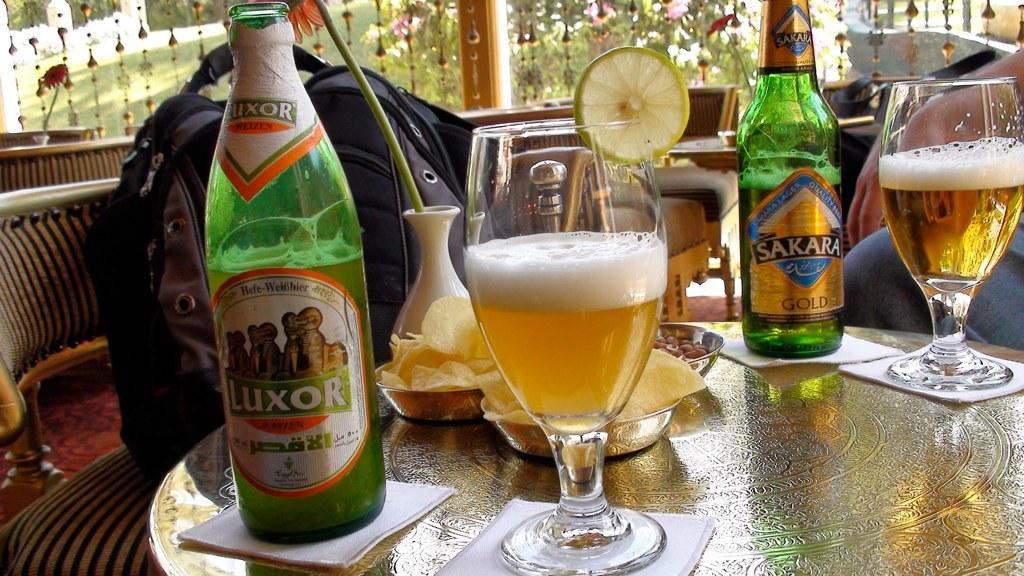What are the names of the beer on the bottles?
Provide a short and direct response. Luxor, sakara. 